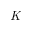<formula> <loc_0><loc_0><loc_500><loc_500>K</formula> 